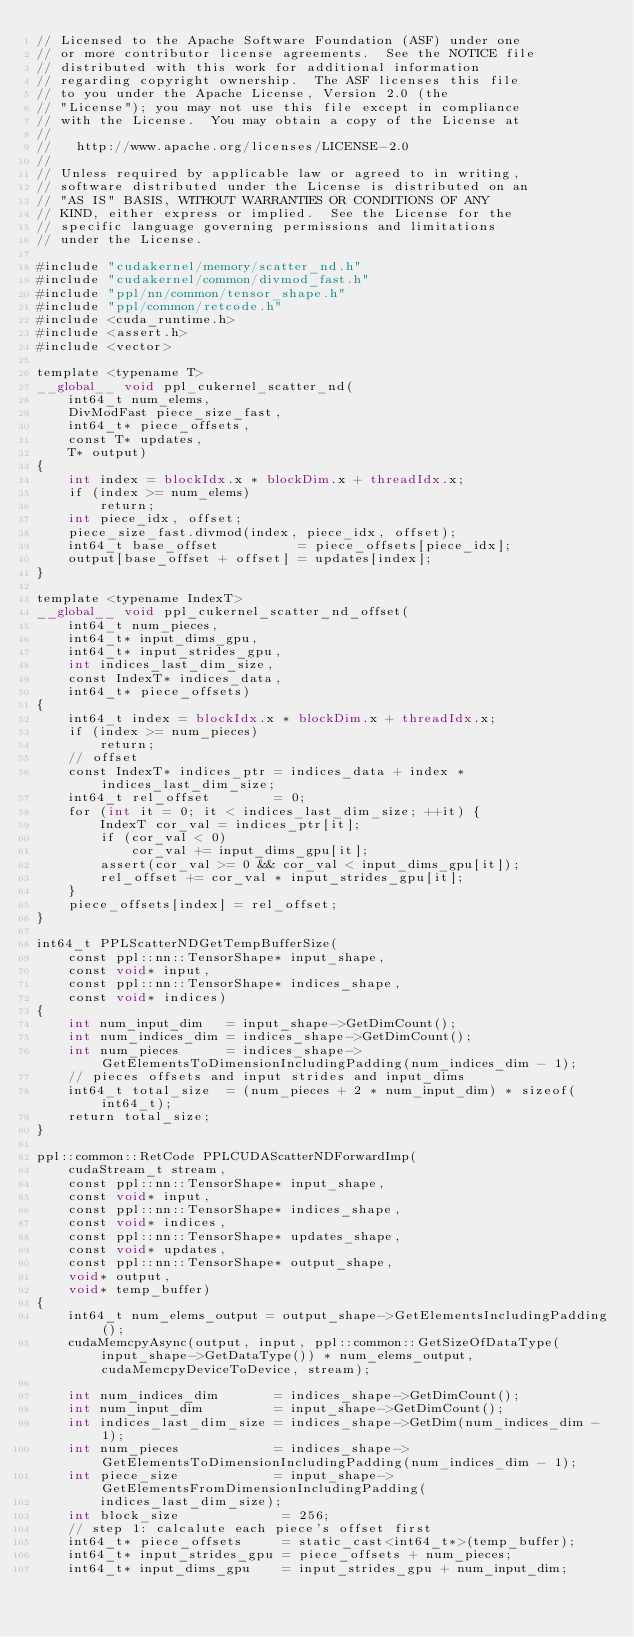Convert code to text. <code><loc_0><loc_0><loc_500><loc_500><_Cuda_>// Licensed to the Apache Software Foundation (ASF) under one
// or more contributor license agreements.  See the NOTICE file
// distributed with this work for additional information
// regarding copyright ownership.  The ASF licenses this file
// to you under the Apache License, Version 2.0 (the
// "License"); you may not use this file except in compliance
// with the License.  You may obtain a copy of the License at
//
//   http://www.apache.org/licenses/LICENSE-2.0
//
// Unless required by applicable law or agreed to in writing,
// software distributed under the License is distributed on an
// "AS IS" BASIS, WITHOUT WARRANTIES OR CONDITIONS OF ANY
// KIND, either express or implied.  See the License for the
// specific language governing permissions and limitations
// under the License.

#include "cudakernel/memory/scatter_nd.h"
#include "cudakernel/common/divmod_fast.h"
#include "ppl/nn/common/tensor_shape.h"
#include "ppl/common/retcode.h"
#include <cuda_runtime.h>
#include <assert.h>
#include <vector>

template <typename T>
__global__ void ppl_cukernel_scatter_nd(
    int64_t num_elems,
    DivModFast piece_size_fast,
    int64_t* piece_offsets,
    const T* updates,
    T* output)
{
    int index = blockIdx.x * blockDim.x + threadIdx.x;
    if (index >= num_elems)
        return;
    int piece_idx, offset;
    piece_size_fast.divmod(index, piece_idx, offset);
    int64_t base_offset          = piece_offsets[piece_idx];
    output[base_offset + offset] = updates[index];
}

template <typename IndexT>
__global__ void ppl_cukernel_scatter_nd_offset(
    int64_t num_pieces,
    int64_t* input_dims_gpu,
    int64_t* input_strides_gpu,
    int indices_last_dim_size,
    const IndexT* indices_data,
    int64_t* piece_offsets)
{
    int64_t index = blockIdx.x * blockDim.x + threadIdx.x;
    if (index >= num_pieces)
        return;
    // offset
    const IndexT* indices_ptr = indices_data + index * indices_last_dim_size;
    int64_t rel_offset        = 0;
    for (int it = 0; it < indices_last_dim_size; ++it) {
        IndexT cor_val = indices_ptr[it];
        if (cor_val < 0)
            cor_val += input_dims_gpu[it];
        assert(cor_val >= 0 && cor_val < input_dims_gpu[it]);
        rel_offset += cor_val * input_strides_gpu[it];
    }
    piece_offsets[index] = rel_offset;
}

int64_t PPLScatterNDGetTempBufferSize(
    const ppl::nn::TensorShape* input_shape,
    const void* input,
    const ppl::nn::TensorShape* indices_shape,
    const void* indices)
{
    int num_input_dim   = input_shape->GetDimCount();
    int num_indices_dim = indices_shape->GetDimCount();
    int num_pieces      = indices_shape->GetElementsToDimensionIncludingPadding(num_indices_dim - 1);
    // pieces offsets and input strides and input_dims
    int64_t total_size  = (num_pieces + 2 * num_input_dim) * sizeof(int64_t);
    return total_size;
}

ppl::common::RetCode PPLCUDAScatterNDForwardImp(
    cudaStream_t stream,
    const ppl::nn::TensorShape* input_shape,
    const void* input,
    const ppl::nn::TensorShape* indices_shape,
    const void* indices,
    const ppl::nn::TensorShape* updates_shape,
    const void* updates,
    const ppl::nn::TensorShape* output_shape,
    void* output,
    void* temp_buffer)
{
    int64_t num_elems_output = output_shape->GetElementsIncludingPadding();
    cudaMemcpyAsync(output, input, ppl::common::GetSizeOfDataType(input_shape->GetDataType()) * num_elems_output, cudaMemcpyDeviceToDevice, stream);

    int num_indices_dim       = indices_shape->GetDimCount();
    int num_input_dim         = input_shape->GetDimCount();
    int indices_last_dim_size = indices_shape->GetDim(num_indices_dim - 1);
    int num_pieces            = indices_shape->GetElementsToDimensionIncludingPadding(num_indices_dim - 1);
    int piece_size            = input_shape->GetElementsFromDimensionIncludingPadding(
        indices_last_dim_size);
    int block_size             = 256;
    // step 1: calcalute each piece's offset first
    int64_t* piece_offsets     = static_cast<int64_t*>(temp_buffer);
    int64_t* input_strides_gpu = piece_offsets + num_pieces;
    int64_t* input_dims_gpu    = input_strides_gpu + num_input_dim;</code> 